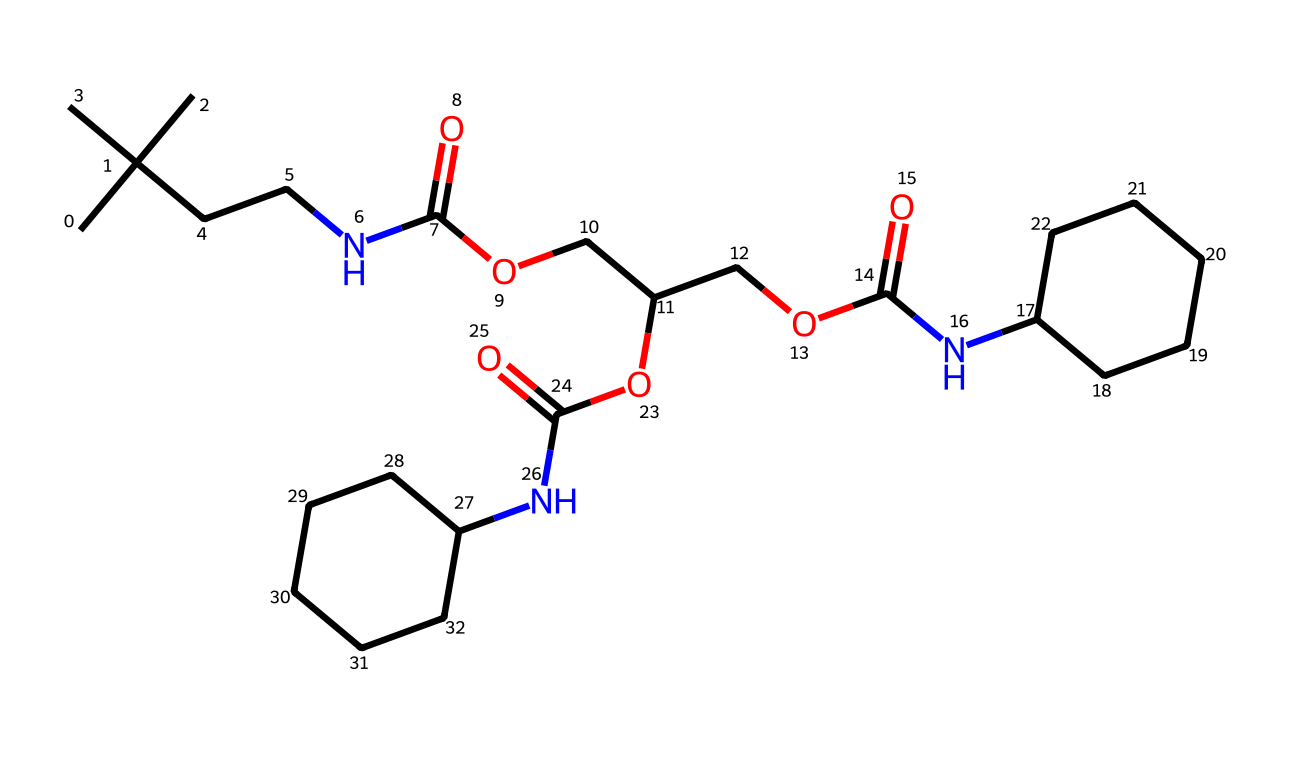What is the total number of carbon atoms in this chemical structure? To determine the number of carbon atoms, we can count the 'C' symbols in the provided SMILES representation. Each 'C' represents a carbon atom, and by counting all occurrences, we find there are 21 carbon atoms.
Answer: 21 How many nitrogen atoms are present in this molecule? In the SMILES string, the nitrogen atoms are represented by 'N'. By locating and counting all instances of 'N', we determine that there are 3 nitrogen atoms in total.
Answer: 3 What functional group is formed by the 'NC(=O)' structures in this chemical? The structure 'NC(=O)' is indicative of an amide functional group, where 'N' represents the nitrogen and 'C(=O)' indicates that it is bonded to a carbonyl (C=O). Each 'NC(=O)' in the compound signifies an amide bond.
Answer: amide Does this compound contain any ester groups? To identify ester groups in the SMILES, we look for the structure 'OC(=O)', which represents the ester functional group. By examining the chemical, we can confirm that there are multiple instances of this structure, supporting the presence of esters.
Answer: yes What is the chemical classification of polyurethane varnish as indicated by its composition? Since the chemical structure reveals the presence of polyfunctional groups, specifically amides and esters, typical of polymer-based compounds, we conclude that this is classified as a non-electrolyte, which does not dissociate in solution.
Answer: non-electrolyte Which type of polymerization likely took place during the synthesis of this varnish? Given that the structure contains repeating units of both amides and esters, this suggests that step-growth polymerization occurred. This method typically involves the reaction of monomers with functional groups forming a polymer chain through the elimination of small molecules like water.
Answer: step-growth polymerization 